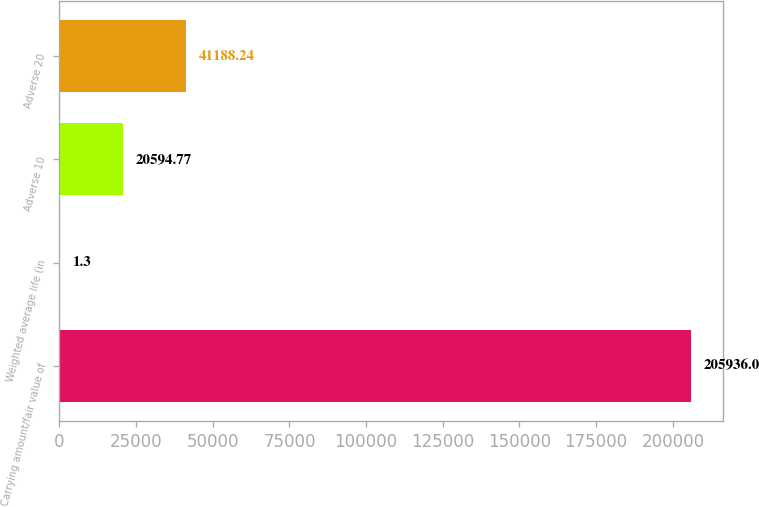<chart> <loc_0><loc_0><loc_500><loc_500><bar_chart><fcel>Carrying amount/fair value of<fcel>Weighted average life (in<fcel>Adverse 10<fcel>Adverse 20<nl><fcel>205936<fcel>1.3<fcel>20594.8<fcel>41188.2<nl></chart> 